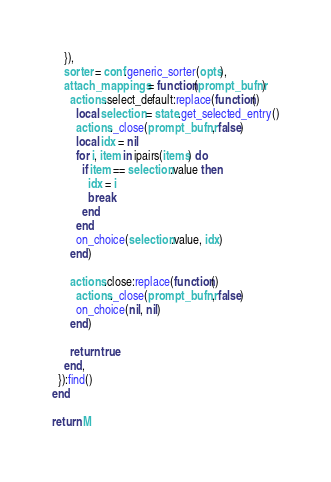<code> <loc_0><loc_0><loc_500><loc_500><_Lua_>    }),
    sorter = conf.generic_sorter(opts),
    attach_mappings = function(prompt_bufnr)
      actions.select_default:replace(function()
        local selection = state.get_selected_entry()
        actions._close(prompt_bufnr, false)
        local idx = nil
        for i, item in ipairs(items) do
          if item == selection.value then
            idx = i
            break
          end
        end
        on_choice(selection.value, idx)
      end)

      actions.close:replace(function()
        actions._close(prompt_bufnr, false)
        on_choice(nil, nil)
      end)

      return true
    end,
  }):find()
end

return M
</code> 